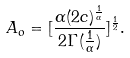Convert formula to latex. <formula><loc_0><loc_0><loc_500><loc_500>A _ { o } = [ \frac { \alpha ( 2 c ) ^ { \frac { 1 } { \alpha } } } { 2 \Gamma ( \frac { 1 } { \alpha } ) } ] ^ { \frac { 1 } { 2 } } .</formula> 